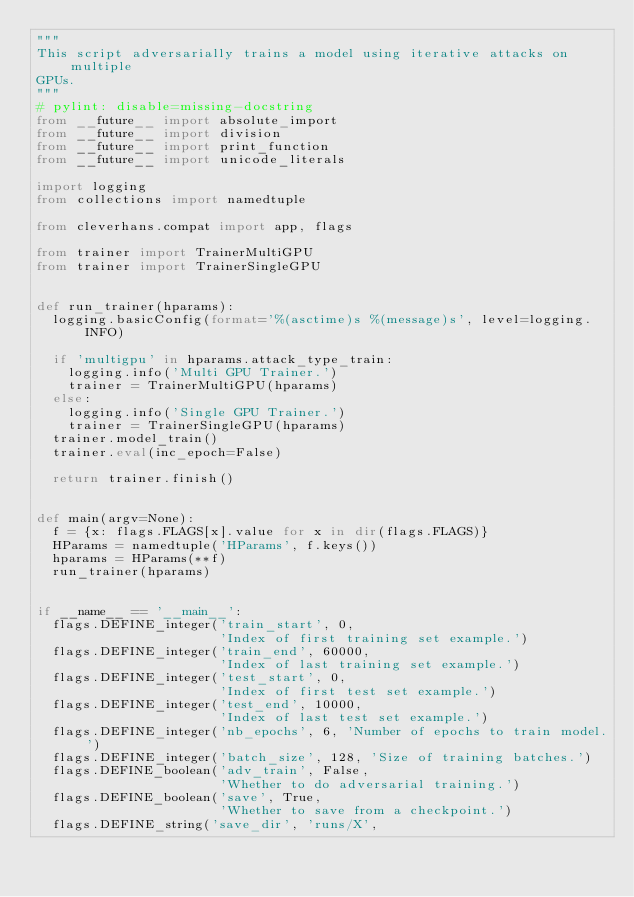Convert code to text. <code><loc_0><loc_0><loc_500><loc_500><_Python_>"""
This script adversarially trains a model using iterative attacks on multiple
GPUs.
"""
# pylint: disable=missing-docstring
from __future__ import absolute_import
from __future__ import division
from __future__ import print_function
from __future__ import unicode_literals

import logging
from collections import namedtuple

from cleverhans.compat import app, flags

from trainer import TrainerMultiGPU
from trainer import TrainerSingleGPU


def run_trainer(hparams):
  logging.basicConfig(format='%(asctime)s %(message)s', level=logging.INFO)

  if 'multigpu' in hparams.attack_type_train:
    logging.info('Multi GPU Trainer.')
    trainer = TrainerMultiGPU(hparams)
  else:
    logging.info('Single GPU Trainer.')
    trainer = TrainerSingleGPU(hparams)
  trainer.model_train()
  trainer.eval(inc_epoch=False)

  return trainer.finish()


def main(argv=None):
  f = {x: flags.FLAGS[x].value for x in dir(flags.FLAGS)}
  HParams = namedtuple('HParams', f.keys())
  hparams = HParams(**f)
  run_trainer(hparams)


if __name__ == '__main__':
  flags.DEFINE_integer('train_start', 0,
                       'Index of first training set example.')
  flags.DEFINE_integer('train_end', 60000,
                       'Index of last training set example.')
  flags.DEFINE_integer('test_start', 0,
                       'Index of first test set example.')
  flags.DEFINE_integer('test_end', 10000,
                       'Index of last test set example.')
  flags.DEFINE_integer('nb_epochs', 6, 'Number of epochs to train model.')
  flags.DEFINE_integer('batch_size', 128, 'Size of training batches.')
  flags.DEFINE_boolean('adv_train', False,
                       'Whether to do adversarial training.')
  flags.DEFINE_boolean('save', True,
                       'Whether to save from a checkpoint.')
  flags.DEFINE_string('save_dir', 'runs/X',</code> 